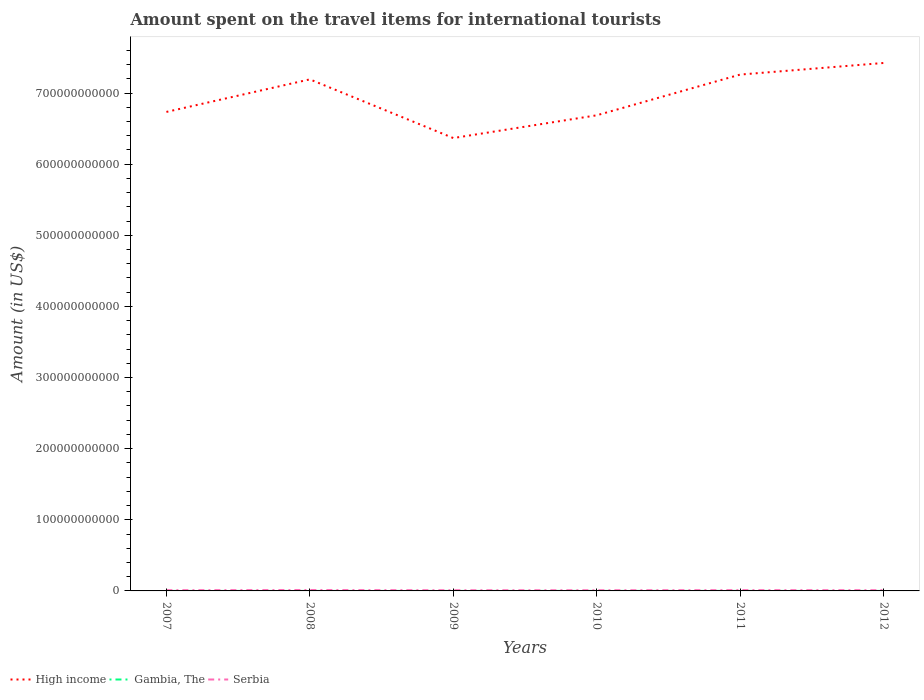Is the number of lines equal to the number of legend labels?
Make the answer very short. Yes. Across all years, what is the maximum amount spent on the travel items for international tourists in Gambia, The?
Your response must be concise. 8.00e+06. In which year was the amount spent on the travel items for international tourists in High income maximum?
Offer a terse response. 2009. What is the total amount spent on the travel items for international tourists in High income in the graph?
Provide a succinct answer. -6.76e+09. What is the difference between the highest and the second highest amount spent on the travel items for international tourists in High income?
Your answer should be compact. 1.06e+11. What is the difference between the highest and the lowest amount spent on the travel items for international tourists in Serbia?
Provide a succinct answer. 2. Is the amount spent on the travel items for international tourists in Gambia, The strictly greater than the amount spent on the travel items for international tourists in Serbia over the years?
Keep it short and to the point. Yes. How many years are there in the graph?
Ensure brevity in your answer.  6. What is the difference between two consecutive major ticks on the Y-axis?
Offer a very short reply. 1.00e+11. Does the graph contain any zero values?
Offer a terse response. No. Where does the legend appear in the graph?
Your response must be concise. Bottom left. How are the legend labels stacked?
Keep it short and to the point. Horizontal. What is the title of the graph?
Offer a very short reply. Amount spent on the travel items for international tourists. Does "Sierra Leone" appear as one of the legend labels in the graph?
Provide a succinct answer. No. What is the label or title of the X-axis?
Your answer should be compact. Years. What is the label or title of the Y-axis?
Make the answer very short. Amount (in US$). What is the Amount (in US$) of High income in 2007?
Keep it short and to the point. 6.73e+11. What is the Amount (in US$) of Gambia, The in 2007?
Your response must be concise. 8.00e+06. What is the Amount (in US$) in Serbia in 2007?
Make the answer very short. 1.04e+09. What is the Amount (in US$) in High income in 2008?
Provide a succinct answer. 7.19e+11. What is the Amount (in US$) in Gambia, The in 2008?
Provide a short and direct response. 8.00e+06. What is the Amount (in US$) of Serbia in 2008?
Offer a very short reply. 1.27e+09. What is the Amount (in US$) of High income in 2009?
Offer a very short reply. 6.37e+11. What is the Amount (in US$) of Gambia, The in 2009?
Offer a terse response. 9.00e+06. What is the Amount (in US$) in Serbia in 2009?
Your answer should be very brief. 9.61e+08. What is the Amount (in US$) of High income in 2010?
Provide a short and direct response. 6.69e+11. What is the Amount (in US$) in Gambia, The in 2010?
Make the answer very short. 1.10e+07. What is the Amount (in US$) of Serbia in 2010?
Your answer should be compact. 9.55e+08. What is the Amount (in US$) of High income in 2011?
Give a very brief answer. 7.26e+11. What is the Amount (in US$) of Gambia, The in 2011?
Ensure brevity in your answer.  1.10e+07. What is the Amount (in US$) in Serbia in 2011?
Offer a very short reply. 1.10e+09. What is the Amount (in US$) in High income in 2012?
Provide a succinct answer. 7.42e+11. What is the Amount (in US$) of Gambia, The in 2012?
Your response must be concise. 8.00e+06. What is the Amount (in US$) of Serbia in 2012?
Ensure brevity in your answer.  1.03e+09. Across all years, what is the maximum Amount (in US$) of High income?
Provide a short and direct response. 7.42e+11. Across all years, what is the maximum Amount (in US$) of Gambia, The?
Offer a very short reply. 1.10e+07. Across all years, what is the maximum Amount (in US$) of Serbia?
Provide a short and direct response. 1.27e+09. Across all years, what is the minimum Amount (in US$) of High income?
Your answer should be very brief. 6.37e+11. Across all years, what is the minimum Amount (in US$) in Serbia?
Give a very brief answer. 9.55e+08. What is the total Amount (in US$) in High income in the graph?
Offer a very short reply. 4.17e+12. What is the total Amount (in US$) of Gambia, The in the graph?
Your response must be concise. 5.50e+07. What is the total Amount (in US$) of Serbia in the graph?
Ensure brevity in your answer.  6.36e+09. What is the difference between the Amount (in US$) of High income in 2007 and that in 2008?
Your answer should be very brief. -4.58e+1. What is the difference between the Amount (in US$) in Serbia in 2007 and that in 2008?
Make the answer very short. -2.28e+08. What is the difference between the Amount (in US$) in High income in 2007 and that in 2009?
Offer a terse response. 3.67e+1. What is the difference between the Amount (in US$) of Gambia, The in 2007 and that in 2009?
Provide a short and direct response. -1.00e+06. What is the difference between the Amount (in US$) of Serbia in 2007 and that in 2009?
Offer a very short reply. 8.00e+07. What is the difference between the Amount (in US$) of High income in 2007 and that in 2010?
Make the answer very short. 4.75e+09. What is the difference between the Amount (in US$) in Serbia in 2007 and that in 2010?
Give a very brief answer. 8.60e+07. What is the difference between the Amount (in US$) of High income in 2007 and that in 2011?
Your answer should be compact. -5.25e+1. What is the difference between the Amount (in US$) in Gambia, The in 2007 and that in 2011?
Give a very brief answer. -3.00e+06. What is the difference between the Amount (in US$) of Serbia in 2007 and that in 2011?
Offer a terse response. -6.40e+07. What is the difference between the Amount (in US$) of High income in 2007 and that in 2012?
Keep it short and to the point. -6.88e+1. What is the difference between the Amount (in US$) in Serbia in 2007 and that in 2012?
Provide a short and direct response. 9.00e+06. What is the difference between the Amount (in US$) in High income in 2008 and that in 2009?
Make the answer very short. 8.25e+1. What is the difference between the Amount (in US$) of Serbia in 2008 and that in 2009?
Your answer should be very brief. 3.08e+08. What is the difference between the Amount (in US$) of High income in 2008 and that in 2010?
Provide a short and direct response. 5.05e+1. What is the difference between the Amount (in US$) in Gambia, The in 2008 and that in 2010?
Provide a succinct answer. -3.00e+06. What is the difference between the Amount (in US$) in Serbia in 2008 and that in 2010?
Ensure brevity in your answer.  3.14e+08. What is the difference between the Amount (in US$) of High income in 2008 and that in 2011?
Make the answer very short. -6.76e+09. What is the difference between the Amount (in US$) in Gambia, The in 2008 and that in 2011?
Your answer should be compact. -3.00e+06. What is the difference between the Amount (in US$) in Serbia in 2008 and that in 2011?
Your response must be concise. 1.64e+08. What is the difference between the Amount (in US$) in High income in 2008 and that in 2012?
Provide a short and direct response. -2.31e+1. What is the difference between the Amount (in US$) in Gambia, The in 2008 and that in 2012?
Give a very brief answer. 0. What is the difference between the Amount (in US$) in Serbia in 2008 and that in 2012?
Provide a short and direct response. 2.37e+08. What is the difference between the Amount (in US$) of High income in 2009 and that in 2010?
Give a very brief answer. -3.20e+1. What is the difference between the Amount (in US$) in High income in 2009 and that in 2011?
Make the answer very short. -8.93e+1. What is the difference between the Amount (in US$) in Gambia, The in 2009 and that in 2011?
Offer a very short reply. -2.00e+06. What is the difference between the Amount (in US$) in Serbia in 2009 and that in 2011?
Ensure brevity in your answer.  -1.44e+08. What is the difference between the Amount (in US$) of High income in 2009 and that in 2012?
Give a very brief answer. -1.06e+11. What is the difference between the Amount (in US$) of Gambia, The in 2009 and that in 2012?
Your answer should be compact. 1.00e+06. What is the difference between the Amount (in US$) of Serbia in 2009 and that in 2012?
Keep it short and to the point. -7.10e+07. What is the difference between the Amount (in US$) of High income in 2010 and that in 2011?
Your answer should be compact. -5.73e+1. What is the difference between the Amount (in US$) in Serbia in 2010 and that in 2011?
Give a very brief answer. -1.50e+08. What is the difference between the Amount (in US$) of High income in 2010 and that in 2012?
Provide a succinct answer. -7.36e+1. What is the difference between the Amount (in US$) in Serbia in 2010 and that in 2012?
Make the answer very short. -7.70e+07. What is the difference between the Amount (in US$) in High income in 2011 and that in 2012?
Your answer should be very brief. -1.63e+1. What is the difference between the Amount (in US$) in Serbia in 2011 and that in 2012?
Keep it short and to the point. 7.30e+07. What is the difference between the Amount (in US$) in High income in 2007 and the Amount (in US$) in Gambia, The in 2008?
Keep it short and to the point. 6.73e+11. What is the difference between the Amount (in US$) of High income in 2007 and the Amount (in US$) of Serbia in 2008?
Your answer should be compact. 6.72e+11. What is the difference between the Amount (in US$) in Gambia, The in 2007 and the Amount (in US$) in Serbia in 2008?
Offer a very short reply. -1.26e+09. What is the difference between the Amount (in US$) in High income in 2007 and the Amount (in US$) in Gambia, The in 2009?
Provide a short and direct response. 6.73e+11. What is the difference between the Amount (in US$) in High income in 2007 and the Amount (in US$) in Serbia in 2009?
Provide a short and direct response. 6.72e+11. What is the difference between the Amount (in US$) of Gambia, The in 2007 and the Amount (in US$) of Serbia in 2009?
Provide a short and direct response. -9.53e+08. What is the difference between the Amount (in US$) of High income in 2007 and the Amount (in US$) of Gambia, The in 2010?
Provide a short and direct response. 6.73e+11. What is the difference between the Amount (in US$) in High income in 2007 and the Amount (in US$) in Serbia in 2010?
Make the answer very short. 6.72e+11. What is the difference between the Amount (in US$) of Gambia, The in 2007 and the Amount (in US$) of Serbia in 2010?
Your response must be concise. -9.47e+08. What is the difference between the Amount (in US$) in High income in 2007 and the Amount (in US$) in Gambia, The in 2011?
Ensure brevity in your answer.  6.73e+11. What is the difference between the Amount (in US$) of High income in 2007 and the Amount (in US$) of Serbia in 2011?
Make the answer very short. 6.72e+11. What is the difference between the Amount (in US$) of Gambia, The in 2007 and the Amount (in US$) of Serbia in 2011?
Offer a very short reply. -1.10e+09. What is the difference between the Amount (in US$) of High income in 2007 and the Amount (in US$) of Gambia, The in 2012?
Provide a succinct answer. 6.73e+11. What is the difference between the Amount (in US$) of High income in 2007 and the Amount (in US$) of Serbia in 2012?
Offer a very short reply. 6.72e+11. What is the difference between the Amount (in US$) of Gambia, The in 2007 and the Amount (in US$) of Serbia in 2012?
Your response must be concise. -1.02e+09. What is the difference between the Amount (in US$) in High income in 2008 and the Amount (in US$) in Gambia, The in 2009?
Your answer should be compact. 7.19e+11. What is the difference between the Amount (in US$) in High income in 2008 and the Amount (in US$) in Serbia in 2009?
Your answer should be compact. 7.18e+11. What is the difference between the Amount (in US$) of Gambia, The in 2008 and the Amount (in US$) of Serbia in 2009?
Provide a short and direct response. -9.53e+08. What is the difference between the Amount (in US$) in High income in 2008 and the Amount (in US$) in Gambia, The in 2010?
Your answer should be very brief. 7.19e+11. What is the difference between the Amount (in US$) of High income in 2008 and the Amount (in US$) of Serbia in 2010?
Give a very brief answer. 7.18e+11. What is the difference between the Amount (in US$) in Gambia, The in 2008 and the Amount (in US$) in Serbia in 2010?
Offer a terse response. -9.47e+08. What is the difference between the Amount (in US$) of High income in 2008 and the Amount (in US$) of Gambia, The in 2011?
Keep it short and to the point. 7.19e+11. What is the difference between the Amount (in US$) of High income in 2008 and the Amount (in US$) of Serbia in 2011?
Provide a short and direct response. 7.18e+11. What is the difference between the Amount (in US$) in Gambia, The in 2008 and the Amount (in US$) in Serbia in 2011?
Give a very brief answer. -1.10e+09. What is the difference between the Amount (in US$) in High income in 2008 and the Amount (in US$) in Gambia, The in 2012?
Give a very brief answer. 7.19e+11. What is the difference between the Amount (in US$) of High income in 2008 and the Amount (in US$) of Serbia in 2012?
Your response must be concise. 7.18e+11. What is the difference between the Amount (in US$) in Gambia, The in 2008 and the Amount (in US$) in Serbia in 2012?
Offer a very short reply. -1.02e+09. What is the difference between the Amount (in US$) of High income in 2009 and the Amount (in US$) of Gambia, The in 2010?
Your answer should be very brief. 6.37e+11. What is the difference between the Amount (in US$) of High income in 2009 and the Amount (in US$) of Serbia in 2010?
Offer a terse response. 6.36e+11. What is the difference between the Amount (in US$) in Gambia, The in 2009 and the Amount (in US$) in Serbia in 2010?
Your response must be concise. -9.46e+08. What is the difference between the Amount (in US$) in High income in 2009 and the Amount (in US$) in Gambia, The in 2011?
Your answer should be compact. 6.37e+11. What is the difference between the Amount (in US$) in High income in 2009 and the Amount (in US$) in Serbia in 2011?
Offer a terse response. 6.36e+11. What is the difference between the Amount (in US$) in Gambia, The in 2009 and the Amount (in US$) in Serbia in 2011?
Your answer should be compact. -1.10e+09. What is the difference between the Amount (in US$) in High income in 2009 and the Amount (in US$) in Gambia, The in 2012?
Provide a succinct answer. 6.37e+11. What is the difference between the Amount (in US$) in High income in 2009 and the Amount (in US$) in Serbia in 2012?
Give a very brief answer. 6.36e+11. What is the difference between the Amount (in US$) in Gambia, The in 2009 and the Amount (in US$) in Serbia in 2012?
Ensure brevity in your answer.  -1.02e+09. What is the difference between the Amount (in US$) of High income in 2010 and the Amount (in US$) of Gambia, The in 2011?
Your response must be concise. 6.69e+11. What is the difference between the Amount (in US$) in High income in 2010 and the Amount (in US$) in Serbia in 2011?
Provide a short and direct response. 6.68e+11. What is the difference between the Amount (in US$) of Gambia, The in 2010 and the Amount (in US$) of Serbia in 2011?
Ensure brevity in your answer.  -1.09e+09. What is the difference between the Amount (in US$) of High income in 2010 and the Amount (in US$) of Gambia, The in 2012?
Your answer should be compact. 6.69e+11. What is the difference between the Amount (in US$) of High income in 2010 and the Amount (in US$) of Serbia in 2012?
Ensure brevity in your answer.  6.68e+11. What is the difference between the Amount (in US$) of Gambia, The in 2010 and the Amount (in US$) of Serbia in 2012?
Your response must be concise. -1.02e+09. What is the difference between the Amount (in US$) in High income in 2011 and the Amount (in US$) in Gambia, The in 2012?
Provide a short and direct response. 7.26e+11. What is the difference between the Amount (in US$) in High income in 2011 and the Amount (in US$) in Serbia in 2012?
Provide a succinct answer. 7.25e+11. What is the difference between the Amount (in US$) of Gambia, The in 2011 and the Amount (in US$) of Serbia in 2012?
Your response must be concise. -1.02e+09. What is the average Amount (in US$) in High income per year?
Your answer should be compact. 6.94e+11. What is the average Amount (in US$) of Gambia, The per year?
Provide a succinct answer. 9.17e+06. What is the average Amount (in US$) in Serbia per year?
Your answer should be compact. 1.06e+09. In the year 2007, what is the difference between the Amount (in US$) in High income and Amount (in US$) in Gambia, The?
Make the answer very short. 6.73e+11. In the year 2007, what is the difference between the Amount (in US$) of High income and Amount (in US$) of Serbia?
Keep it short and to the point. 6.72e+11. In the year 2007, what is the difference between the Amount (in US$) of Gambia, The and Amount (in US$) of Serbia?
Give a very brief answer. -1.03e+09. In the year 2008, what is the difference between the Amount (in US$) in High income and Amount (in US$) in Gambia, The?
Provide a succinct answer. 7.19e+11. In the year 2008, what is the difference between the Amount (in US$) of High income and Amount (in US$) of Serbia?
Your answer should be very brief. 7.18e+11. In the year 2008, what is the difference between the Amount (in US$) of Gambia, The and Amount (in US$) of Serbia?
Give a very brief answer. -1.26e+09. In the year 2009, what is the difference between the Amount (in US$) of High income and Amount (in US$) of Gambia, The?
Keep it short and to the point. 6.37e+11. In the year 2009, what is the difference between the Amount (in US$) of High income and Amount (in US$) of Serbia?
Keep it short and to the point. 6.36e+11. In the year 2009, what is the difference between the Amount (in US$) in Gambia, The and Amount (in US$) in Serbia?
Keep it short and to the point. -9.52e+08. In the year 2010, what is the difference between the Amount (in US$) in High income and Amount (in US$) in Gambia, The?
Ensure brevity in your answer.  6.69e+11. In the year 2010, what is the difference between the Amount (in US$) in High income and Amount (in US$) in Serbia?
Provide a short and direct response. 6.68e+11. In the year 2010, what is the difference between the Amount (in US$) in Gambia, The and Amount (in US$) in Serbia?
Keep it short and to the point. -9.44e+08. In the year 2011, what is the difference between the Amount (in US$) in High income and Amount (in US$) in Gambia, The?
Offer a very short reply. 7.26e+11. In the year 2011, what is the difference between the Amount (in US$) in High income and Amount (in US$) in Serbia?
Offer a very short reply. 7.25e+11. In the year 2011, what is the difference between the Amount (in US$) in Gambia, The and Amount (in US$) in Serbia?
Ensure brevity in your answer.  -1.09e+09. In the year 2012, what is the difference between the Amount (in US$) in High income and Amount (in US$) in Gambia, The?
Provide a succinct answer. 7.42e+11. In the year 2012, what is the difference between the Amount (in US$) of High income and Amount (in US$) of Serbia?
Ensure brevity in your answer.  7.41e+11. In the year 2012, what is the difference between the Amount (in US$) in Gambia, The and Amount (in US$) in Serbia?
Ensure brevity in your answer.  -1.02e+09. What is the ratio of the Amount (in US$) of High income in 2007 to that in 2008?
Ensure brevity in your answer.  0.94. What is the ratio of the Amount (in US$) in Gambia, The in 2007 to that in 2008?
Make the answer very short. 1. What is the ratio of the Amount (in US$) in Serbia in 2007 to that in 2008?
Provide a succinct answer. 0.82. What is the ratio of the Amount (in US$) in High income in 2007 to that in 2009?
Give a very brief answer. 1.06. What is the ratio of the Amount (in US$) of Serbia in 2007 to that in 2009?
Your answer should be compact. 1.08. What is the ratio of the Amount (in US$) in High income in 2007 to that in 2010?
Give a very brief answer. 1.01. What is the ratio of the Amount (in US$) of Gambia, The in 2007 to that in 2010?
Ensure brevity in your answer.  0.73. What is the ratio of the Amount (in US$) of Serbia in 2007 to that in 2010?
Ensure brevity in your answer.  1.09. What is the ratio of the Amount (in US$) in High income in 2007 to that in 2011?
Your answer should be very brief. 0.93. What is the ratio of the Amount (in US$) in Gambia, The in 2007 to that in 2011?
Provide a short and direct response. 0.73. What is the ratio of the Amount (in US$) in Serbia in 2007 to that in 2011?
Offer a terse response. 0.94. What is the ratio of the Amount (in US$) of High income in 2007 to that in 2012?
Your answer should be very brief. 0.91. What is the ratio of the Amount (in US$) in Serbia in 2007 to that in 2012?
Provide a succinct answer. 1.01. What is the ratio of the Amount (in US$) in High income in 2008 to that in 2009?
Your answer should be compact. 1.13. What is the ratio of the Amount (in US$) in Gambia, The in 2008 to that in 2009?
Your response must be concise. 0.89. What is the ratio of the Amount (in US$) in Serbia in 2008 to that in 2009?
Ensure brevity in your answer.  1.32. What is the ratio of the Amount (in US$) in High income in 2008 to that in 2010?
Make the answer very short. 1.08. What is the ratio of the Amount (in US$) of Gambia, The in 2008 to that in 2010?
Ensure brevity in your answer.  0.73. What is the ratio of the Amount (in US$) of Serbia in 2008 to that in 2010?
Keep it short and to the point. 1.33. What is the ratio of the Amount (in US$) in High income in 2008 to that in 2011?
Provide a short and direct response. 0.99. What is the ratio of the Amount (in US$) of Gambia, The in 2008 to that in 2011?
Keep it short and to the point. 0.73. What is the ratio of the Amount (in US$) of Serbia in 2008 to that in 2011?
Ensure brevity in your answer.  1.15. What is the ratio of the Amount (in US$) of High income in 2008 to that in 2012?
Provide a short and direct response. 0.97. What is the ratio of the Amount (in US$) in Serbia in 2008 to that in 2012?
Provide a succinct answer. 1.23. What is the ratio of the Amount (in US$) in High income in 2009 to that in 2010?
Make the answer very short. 0.95. What is the ratio of the Amount (in US$) of Gambia, The in 2009 to that in 2010?
Keep it short and to the point. 0.82. What is the ratio of the Amount (in US$) of Serbia in 2009 to that in 2010?
Your answer should be compact. 1.01. What is the ratio of the Amount (in US$) in High income in 2009 to that in 2011?
Offer a terse response. 0.88. What is the ratio of the Amount (in US$) of Gambia, The in 2009 to that in 2011?
Your answer should be very brief. 0.82. What is the ratio of the Amount (in US$) in Serbia in 2009 to that in 2011?
Your answer should be compact. 0.87. What is the ratio of the Amount (in US$) in High income in 2009 to that in 2012?
Your response must be concise. 0.86. What is the ratio of the Amount (in US$) in Serbia in 2009 to that in 2012?
Your answer should be very brief. 0.93. What is the ratio of the Amount (in US$) in High income in 2010 to that in 2011?
Give a very brief answer. 0.92. What is the ratio of the Amount (in US$) in Gambia, The in 2010 to that in 2011?
Make the answer very short. 1. What is the ratio of the Amount (in US$) of Serbia in 2010 to that in 2011?
Ensure brevity in your answer.  0.86. What is the ratio of the Amount (in US$) of High income in 2010 to that in 2012?
Make the answer very short. 0.9. What is the ratio of the Amount (in US$) of Gambia, The in 2010 to that in 2012?
Your answer should be compact. 1.38. What is the ratio of the Amount (in US$) of Serbia in 2010 to that in 2012?
Provide a short and direct response. 0.93. What is the ratio of the Amount (in US$) of High income in 2011 to that in 2012?
Offer a terse response. 0.98. What is the ratio of the Amount (in US$) in Gambia, The in 2011 to that in 2012?
Your answer should be compact. 1.38. What is the ratio of the Amount (in US$) of Serbia in 2011 to that in 2012?
Make the answer very short. 1.07. What is the difference between the highest and the second highest Amount (in US$) in High income?
Your answer should be very brief. 1.63e+1. What is the difference between the highest and the second highest Amount (in US$) of Serbia?
Your response must be concise. 1.64e+08. What is the difference between the highest and the lowest Amount (in US$) of High income?
Your answer should be very brief. 1.06e+11. What is the difference between the highest and the lowest Amount (in US$) of Gambia, The?
Offer a terse response. 3.00e+06. What is the difference between the highest and the lowest Amount (in US$) of Serbia?
Provide a succinct answer. 3.14e+08. 